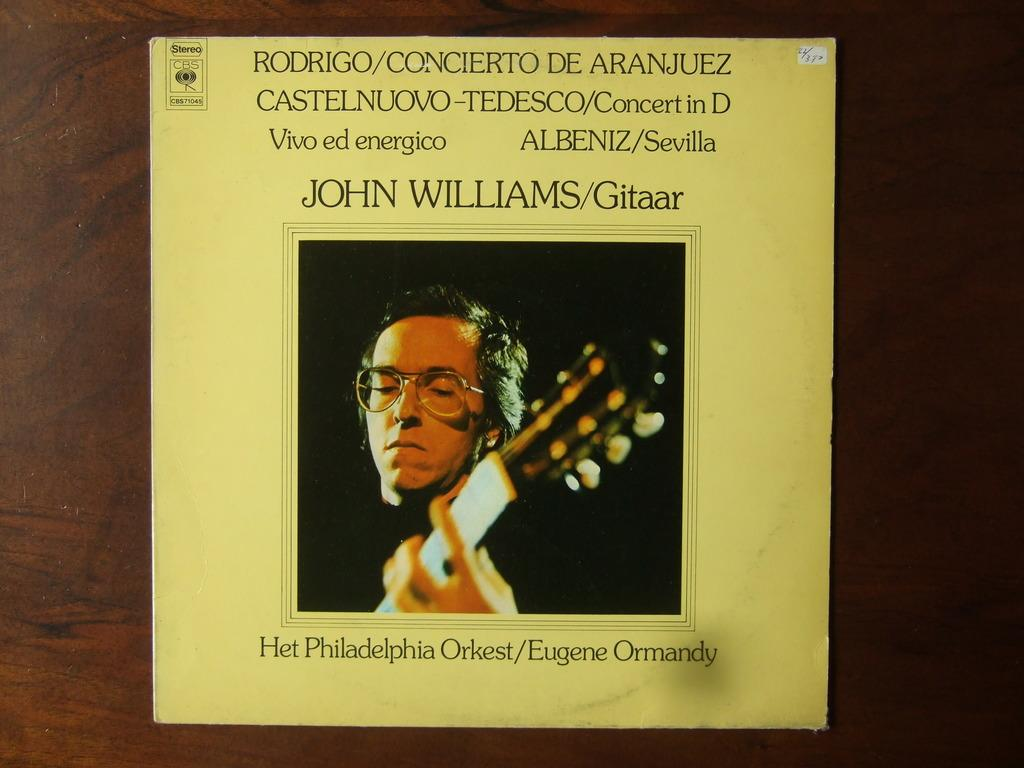<image>
Offer a succinct explanation of the picture presented. A CBS record album that features John Williams. 